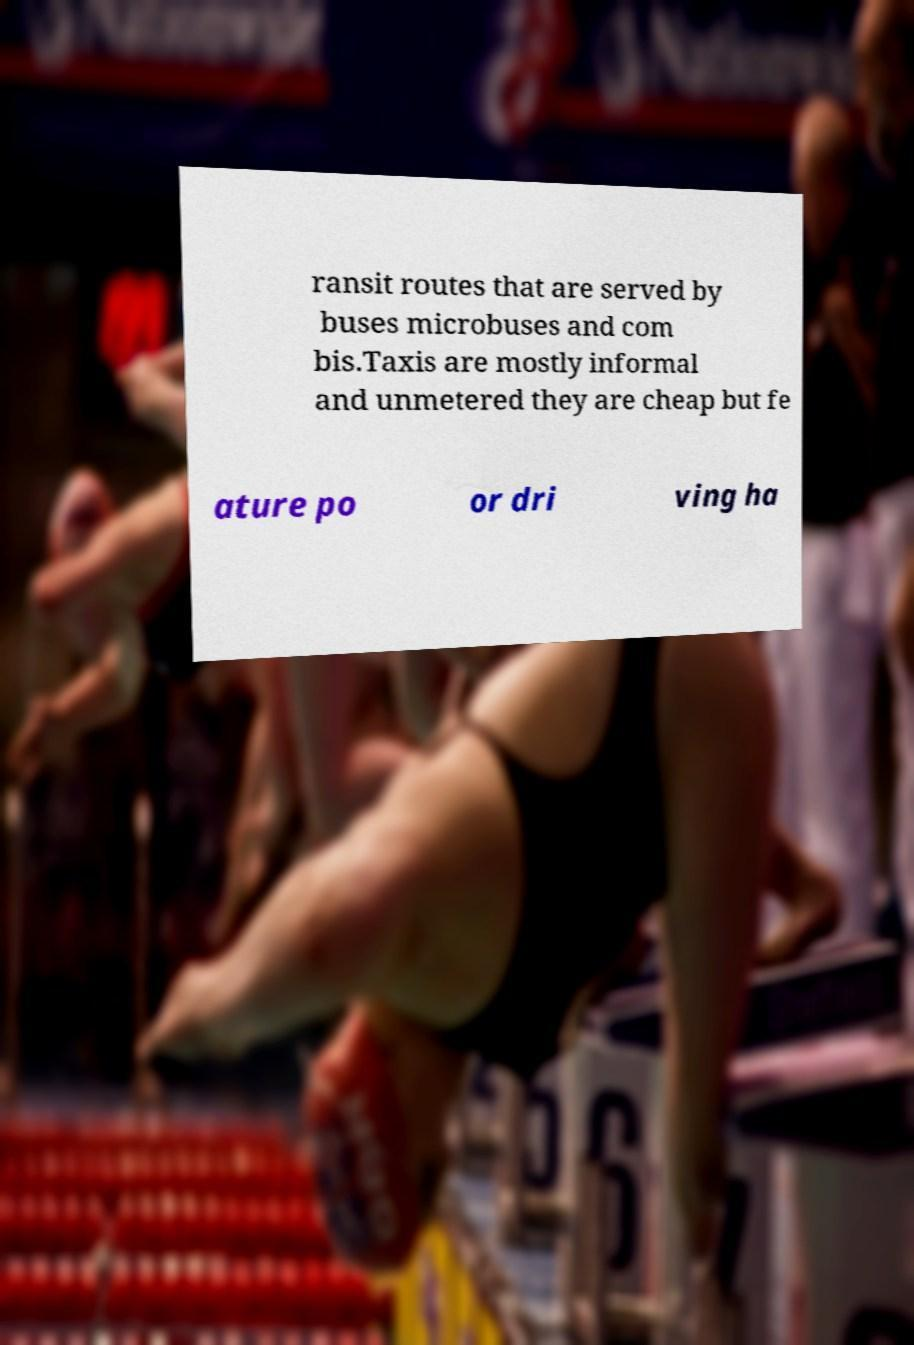Please identify and transcribe the text found in this image. ransit routes that are served by buses microbuses and com bis.Taxis are mostly informal and unmetered they are cheap but fe ature po or dri ving ha 